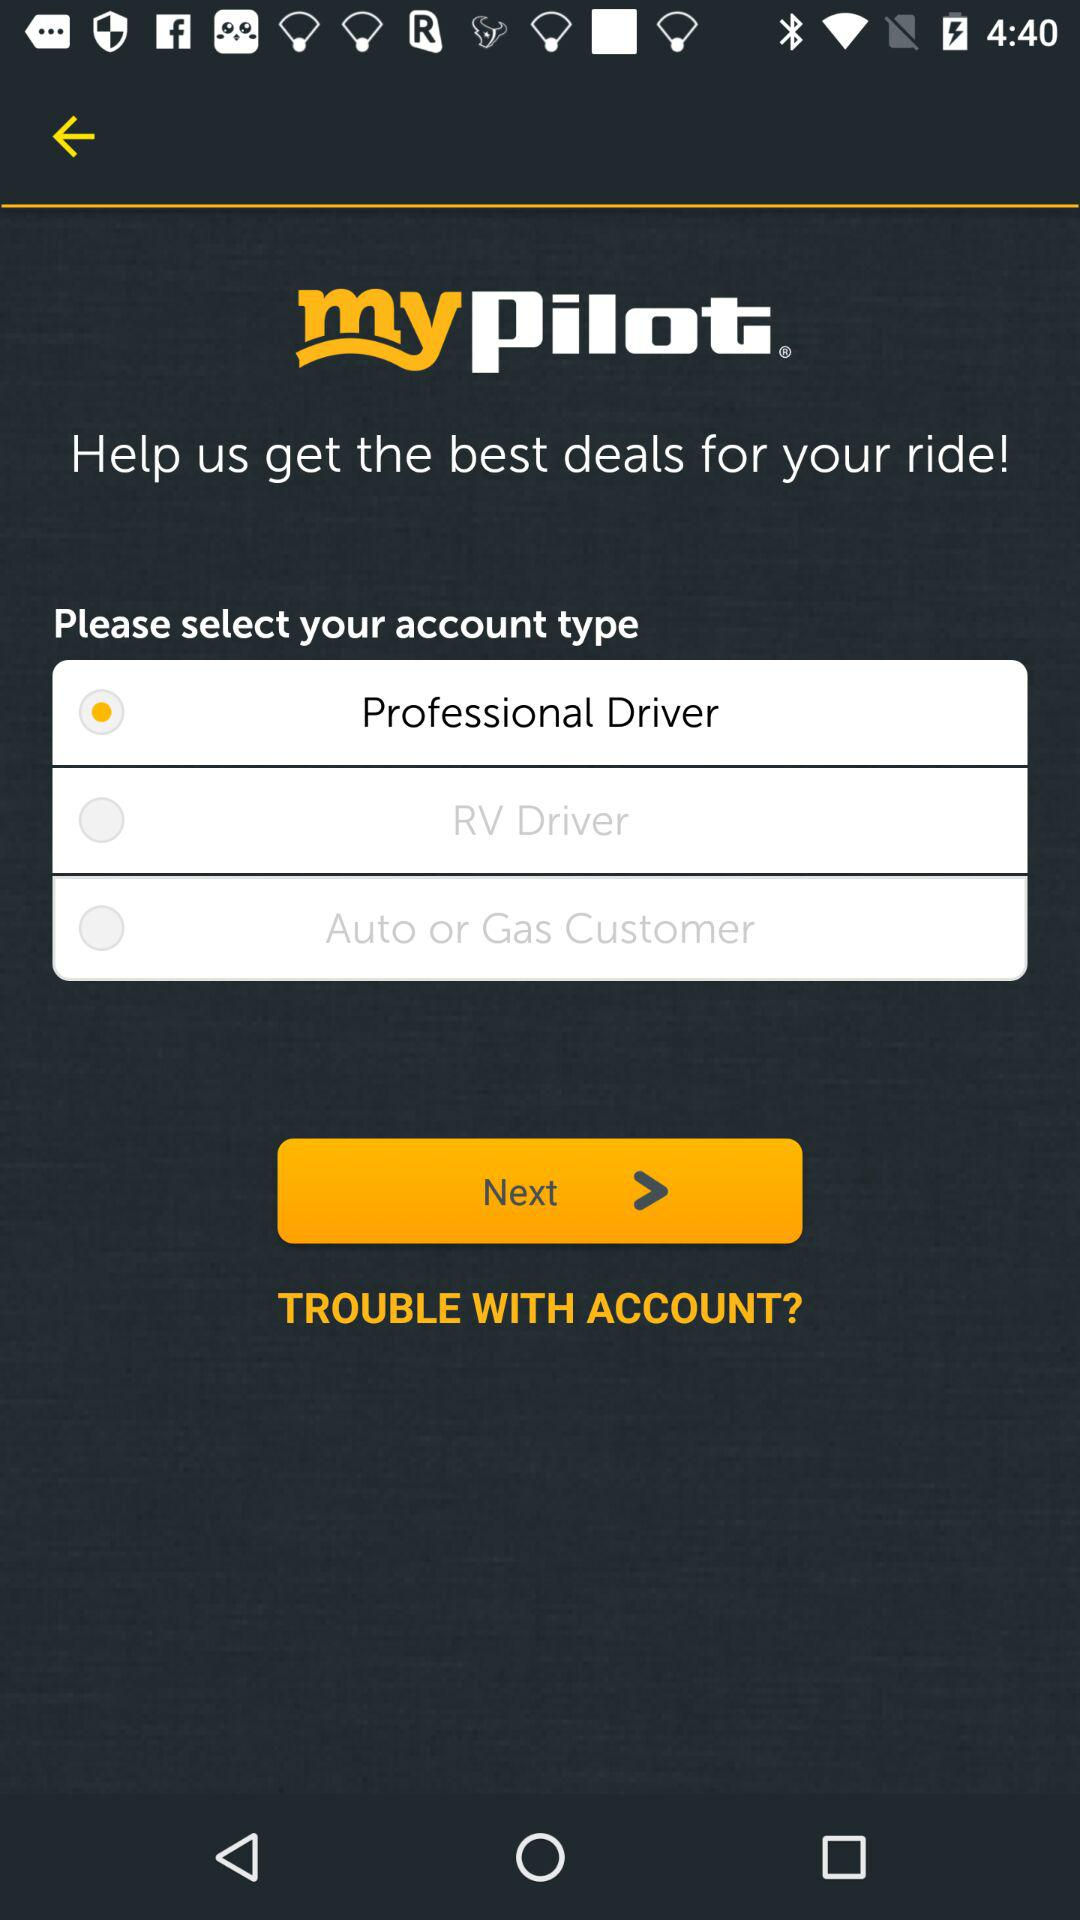What is the name of the application? The name of the application is "mypilot". 